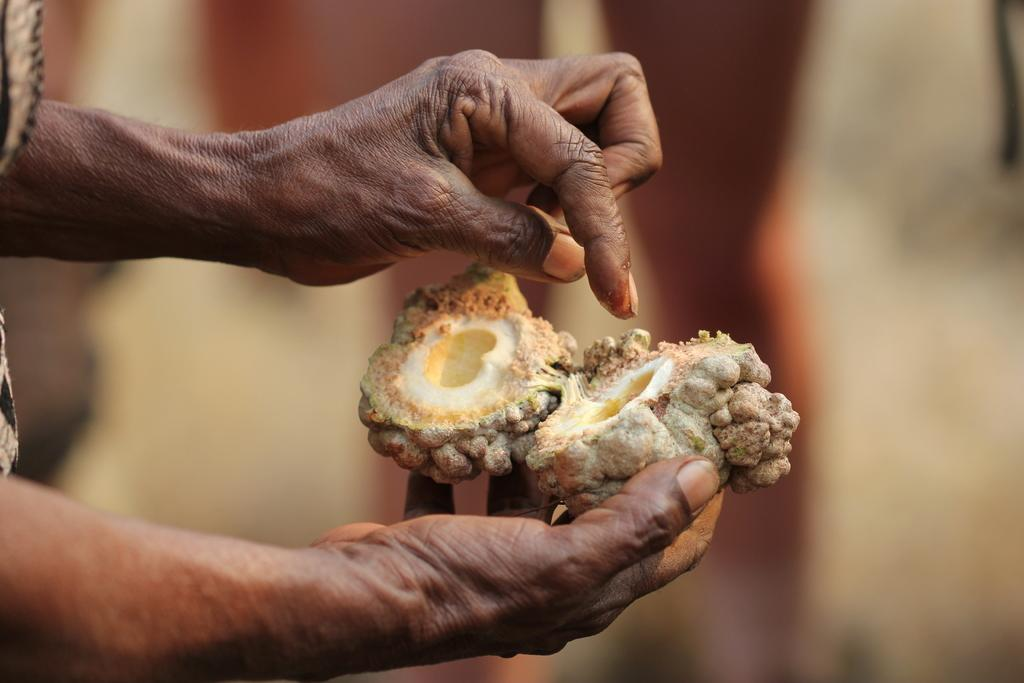What is the main subject of the image? There is a person in the image. What is the person holding in the image? The person is holding a fruit. Can you describe the background of the image? The background of the image is blurry. What type of credit can be seen being exchanged between the person and the vendor in the image? There is no vendor or credit exchange present in the image; it only shows a person holding a fruit. What type of sleet is falling in the background of the image? There is no sleet present in the image; the background is blurry, but no precipitation is visible. 